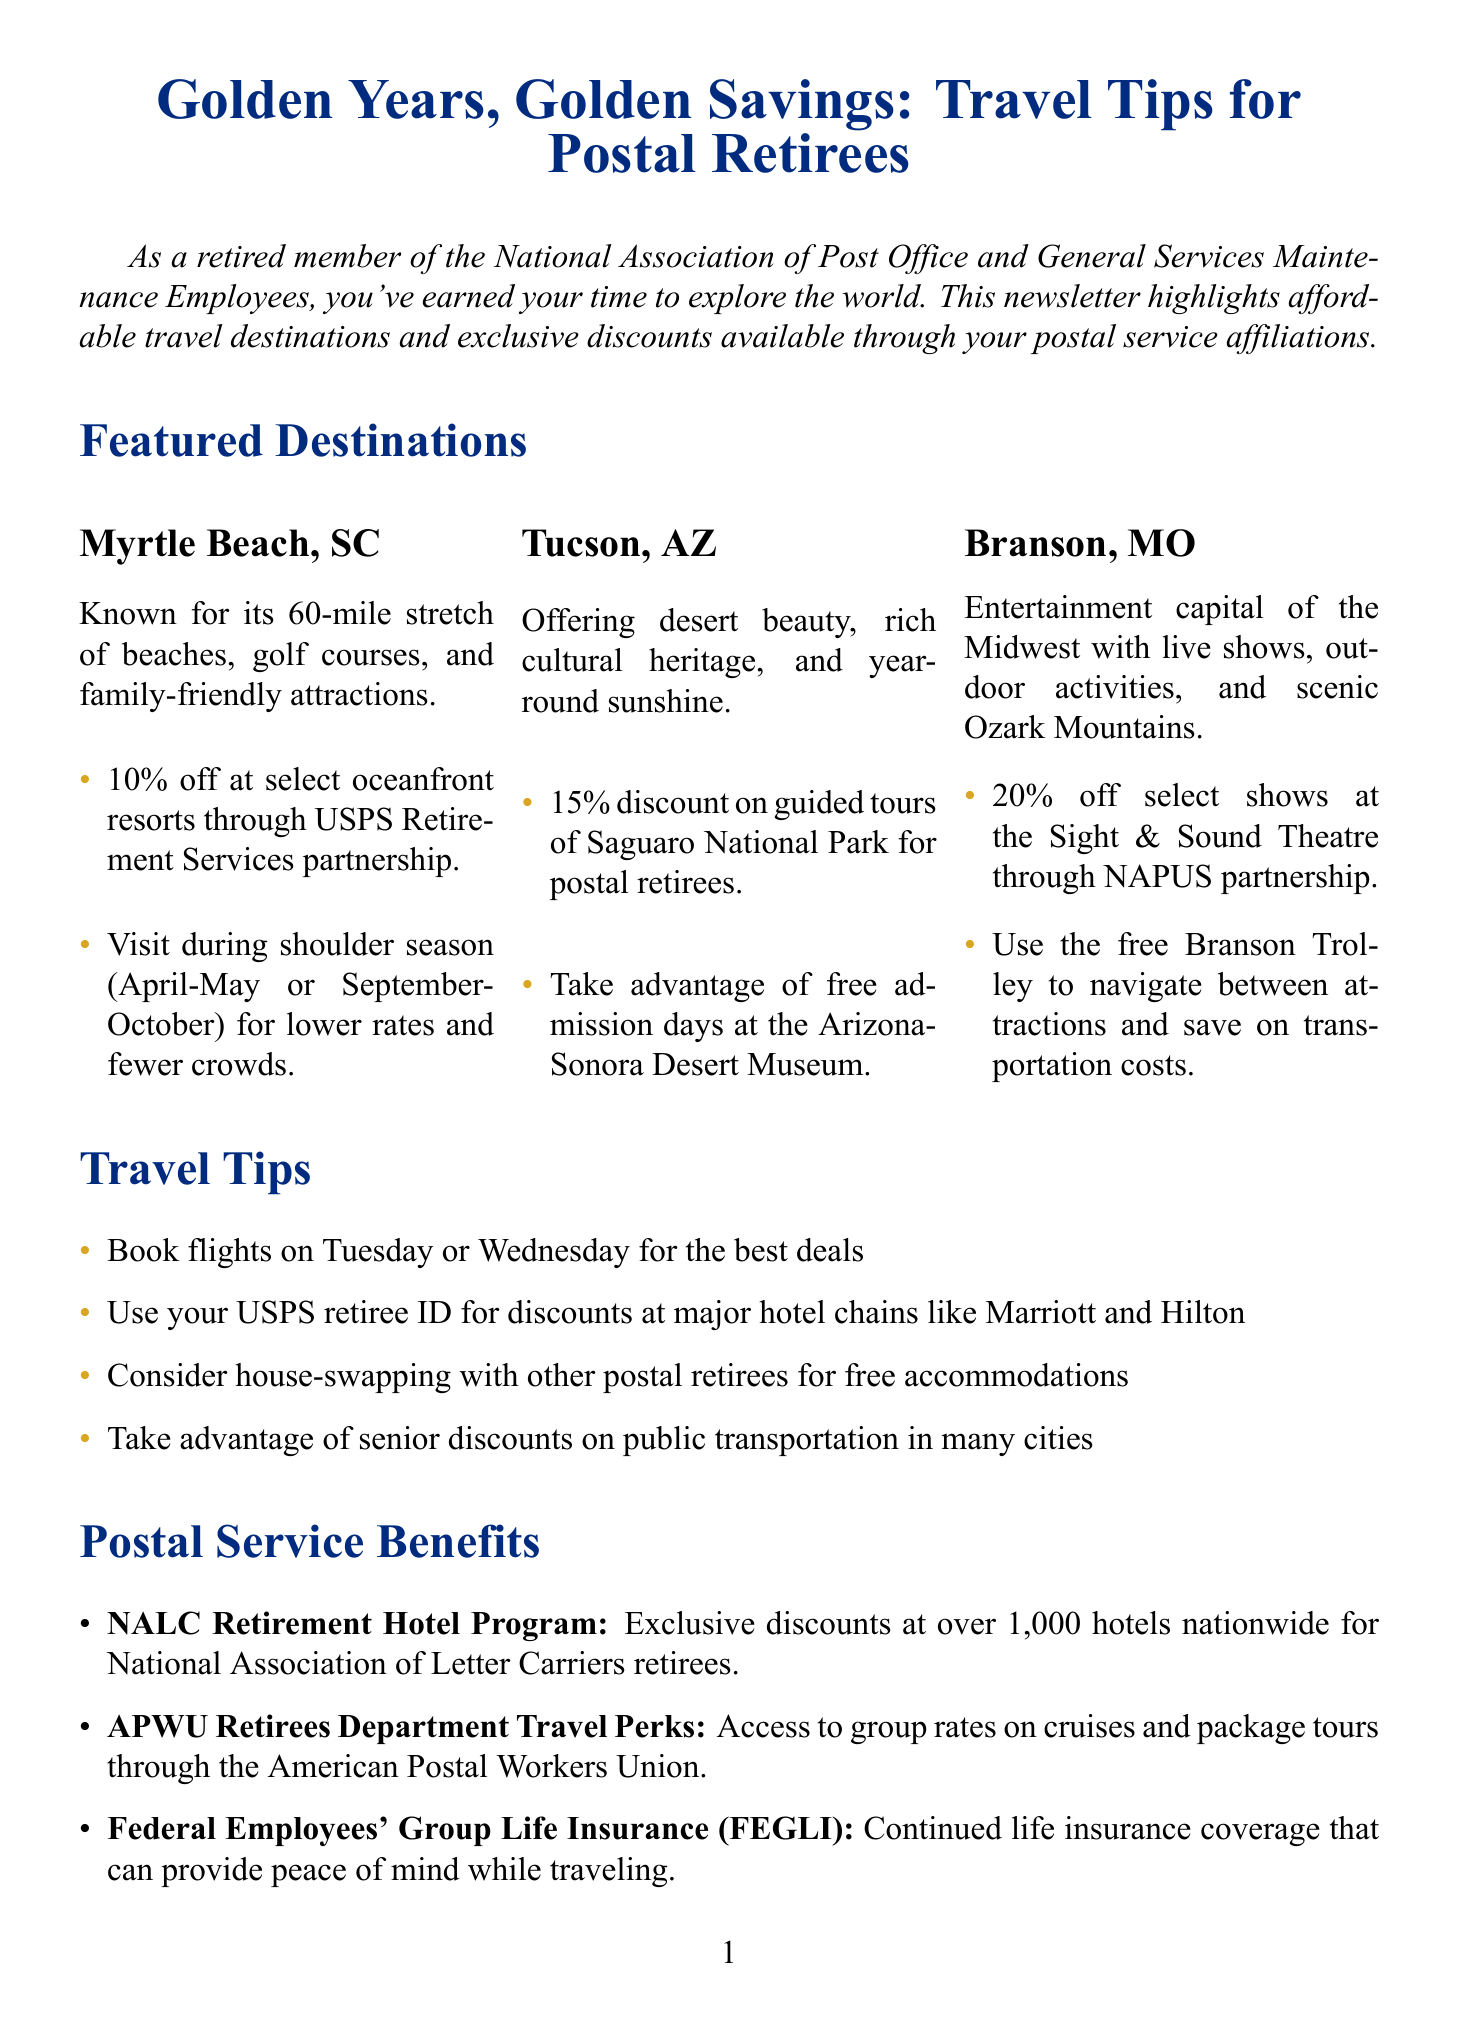what is the title of the newsletter? The title is clearly stated at the beginning of the document as "Golden Years, Golden Savings: Travel Tips for Postal Retirees."
Answer: Golden Years, Golden Savings: Travel Tips for Postal Retirees what is one destination featured in the newsletter? The document lists several destinations, and one of them is Myrtle Beach, South Carolina.
Answer: Myrtle Beach, South Carolina how much discount is offered at Myrtle Beach resorts? The discount for oceanfront resorts through USPS Retirement Services is mentioned in the document.
Answer: 10% off when does the National Postal Forum 2023 take place? The document specifies the date range for the event.
Answer: May 21-24, 2023 what benefit is available for National Association of Letter Carriers retirees? The document discusses various benefits, including a specific hotel program for NALC retirees.
Answer: NALC Retirement Hotel Program what is a budget tip for Tucson? The newsletter provides budget tips for each destination, and one is specific to Tucson.
Answer: Take advantage of free admission days at the Arizona-Sonora Desert Museum which city is known as the entertainment capital of the Midwest? The document describes this city in its featured destinations section.
Answer: Branson, Missouri what should retirees carry when traveling for health and safety? The document emphasizes this as a crucial health and safety reminder.
Answer: Medicare card what type of discounts are postal retirees encouraged to use at major hotel chains? This recommendation is made in the travel tips section of the document.
Answer: USPS retiree ID 